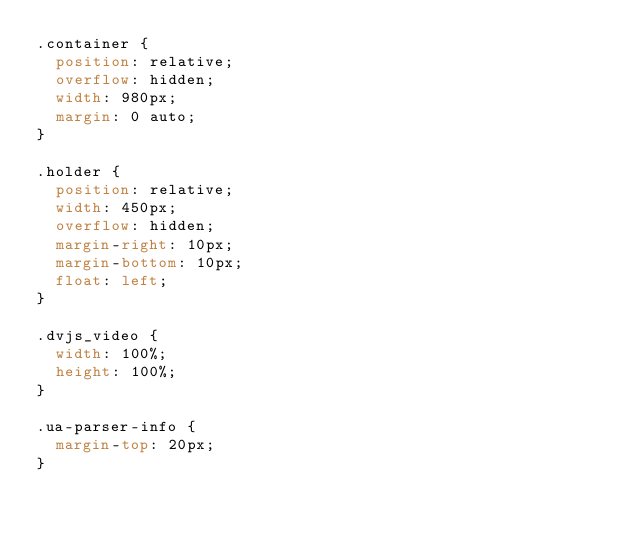Convert code to text. <code><loc_0><loc_0><loc_500><loc_500><_CSS_>.container {
  position: relative;
  overflow: hidden;
  width: 980px;
  margin: 0 auto;
}

.holder {
  position: relative;
  width: 450px;
  overflow: hidden;
  margin-right: 10px;
  margin-bottom: 10px;
  float: left;
}

.dvjs_video {
  width: 100%;
  height: 100%;
}

.ua-parser-info {
  margin-top: 20px;
}
</code> 